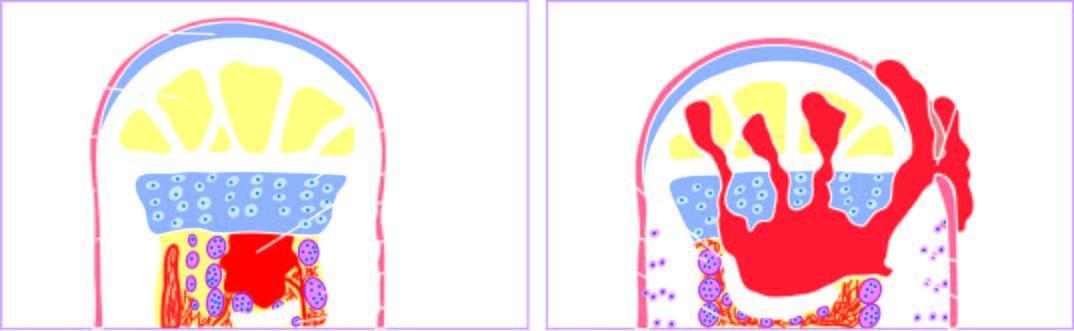s an asbestos body called involucrum?
Answer the question using a single word or phrase. No 